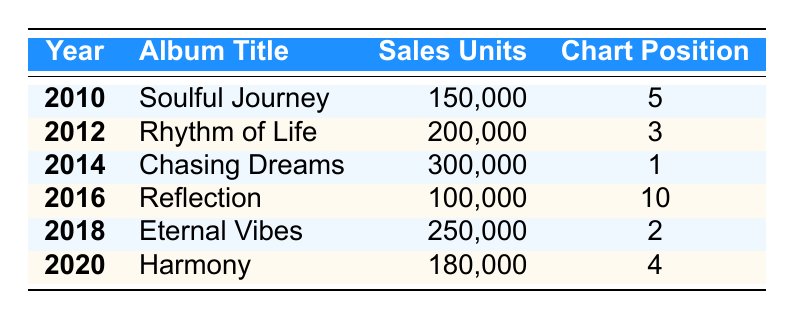What is the total number of album sales units across all years? To find the total number of album sales units, we need to sum the sales units for each album listed: 150000 + 200000 + 300000 + 100000 + 250000 + 180000 = 1180000
Answer: 1180000 Which album had the highest chart position, and what was that position? The highest chart position can be found by examining the "chart position" column. The lowest number in this column is 1, which corresponds to the album "Chasing Dreams."
Answer: Chasing Dreams, 1 In which year did Jamie Archer achieve the most sales units? We can find the year with the highest sales units by looking at the "sales units" column. The highest value is 300000, which corresponds to the year 2014 with the album "Chasing Dreams."
Answer: 2014 How many albums had sales units greater than 200000? Reviewing the sales units, we can see that two albums had sales units greater than 200000: "Rhythm of Life" (200000) and "Chasing Dreams" (300000). Therefore, 1 album had sales units exceeding 200000.
Answer: 1 Is it true that Jamie Archer's album "Reflection" was released in an even-numbered year? The year of "Reflection" is 2016, which is an even number. Therefore, the statement is true.
Answer: Yes What is the average sales units of Jamie Archer's albums? To calculate the average, we need to sum the sales units (1180000) and divide by the number of albums (6). So, 1180000 / 6 = 196666.67, rounded to 196667.
Answer: 196667 Which album's sales units were closest to the average sales units? We first calculated the average sales units (196667). Now we check the sales units for each album and see that "Harmony" (180000) is closest to the average with a difference of 16667.
Answer: Harmony What is the difference in sales units between the album with the highest and the album with the lowest sales? The highest is "Chasing Dreams" with 300000, and the lowest is "Reflection" with 100000. The difference is 300000 - 100000 = 200000.
Answer: 200000 